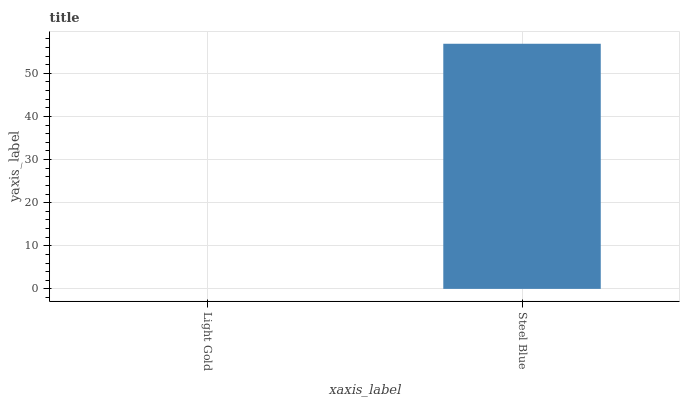Is Light Gold the minimum?
Answer yes or no. Yes. Is Steel Blue the maximum?
Answer yes or no. Yes. Is Steel Blue the minimum?
Answer yes or no. No. Is Steel Blue greater than Light Gold?
Answer yes or no. Yes. Is Light Gold less than Steel Blue?
Answer yes or no. Yes. Is Light Gold greater than Steel Blue?
Answer yes or no. No. Is Steel Blue less than Light Gold?
Answer yes or no. No. Is Steel Blue the high median?
Answer yes or no. Yes. Is Light Gold the low median?
Answer yes or no. Yes. Is Light Gold the high median?
Answer yes or no. No. Is Steel Blue the low median?
Answer yes or no. No. 